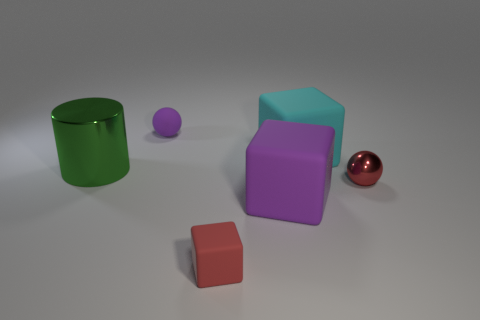What number of small purple things have the same shape as the large purple object?
Give a very brief answer. 0. There is a thing to the right of the cube that is behind the tiny shiny object in front of the purple sphere; what is its color?
Provide a succinct answer. Red. Do the red thing behind the tiny red matte cube and the thing that is behind the cyan block have the same material?
Offer a terse response. No. How many things are red objects that are to the right of the red cube or tiny matte things?
Offer a terse response. 3. What number of objects are purple matte things or things that are on the right side of the small purple rubber sphere?
Make the answer very short. 5. How many cyan shiny cubes are the same size as the red block?
Your response must be concise. 0. Is the number of tiny matte balls in front of the red rubber thing less than the number of things that are behind the big cyan rubber thing?
Offer a very short reply. Yes. How many shiny things are either big blue cylinders or purple cubes?
Provide a short and direct response. 0. What is the shape of the small red shiny object?
Your response must be concise. Sphere. There is a red sphere that is the same size as the purple rubber sphere; what is its material?
Offer a terse response. Metal. 